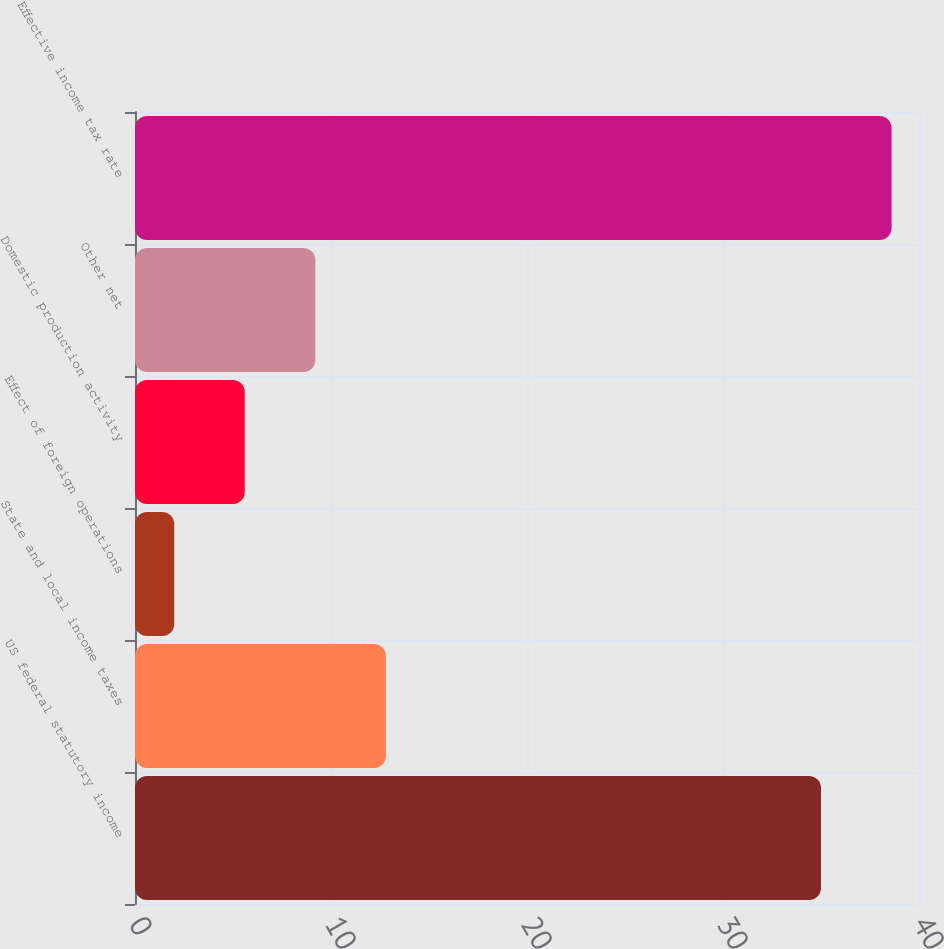Convert chart to OTSL. <chart><loc_0><loc_0><loc_500><loc_500><bar_chart><fcel>US federal statutory income<fcel>State and local income taxes<fcel>Effect of foreign operations<fcel>Domestic production activity<fcel>Other net<fcel>Effective income tax rate<nl><fcel>35<fcel>12.8<fcel>2<fcel>5.6<fcel>9.2<fcel>38.6<nl></chart> 